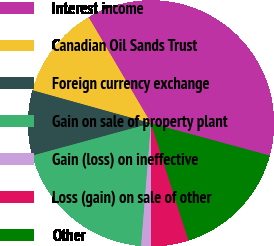<chart> <loc_0><loc_0><loc_500><loc_500><pie_chart><fcel>Interest income<fcel>Canadian Oil Sands Trust<fcel>Foreign currency exchange<fcel>Gain on sale of property plant<fcel>Gain (loss) on ineffective<fcel>Loss (gain) on sale of other<fcel>Other<nl><fcel>37.7%<fcel>12.2%<fcel>8.56%<fcel>19.49%<fcel>1.28%<fcel>4.92%<fcel>15.85%<nl></chart> 